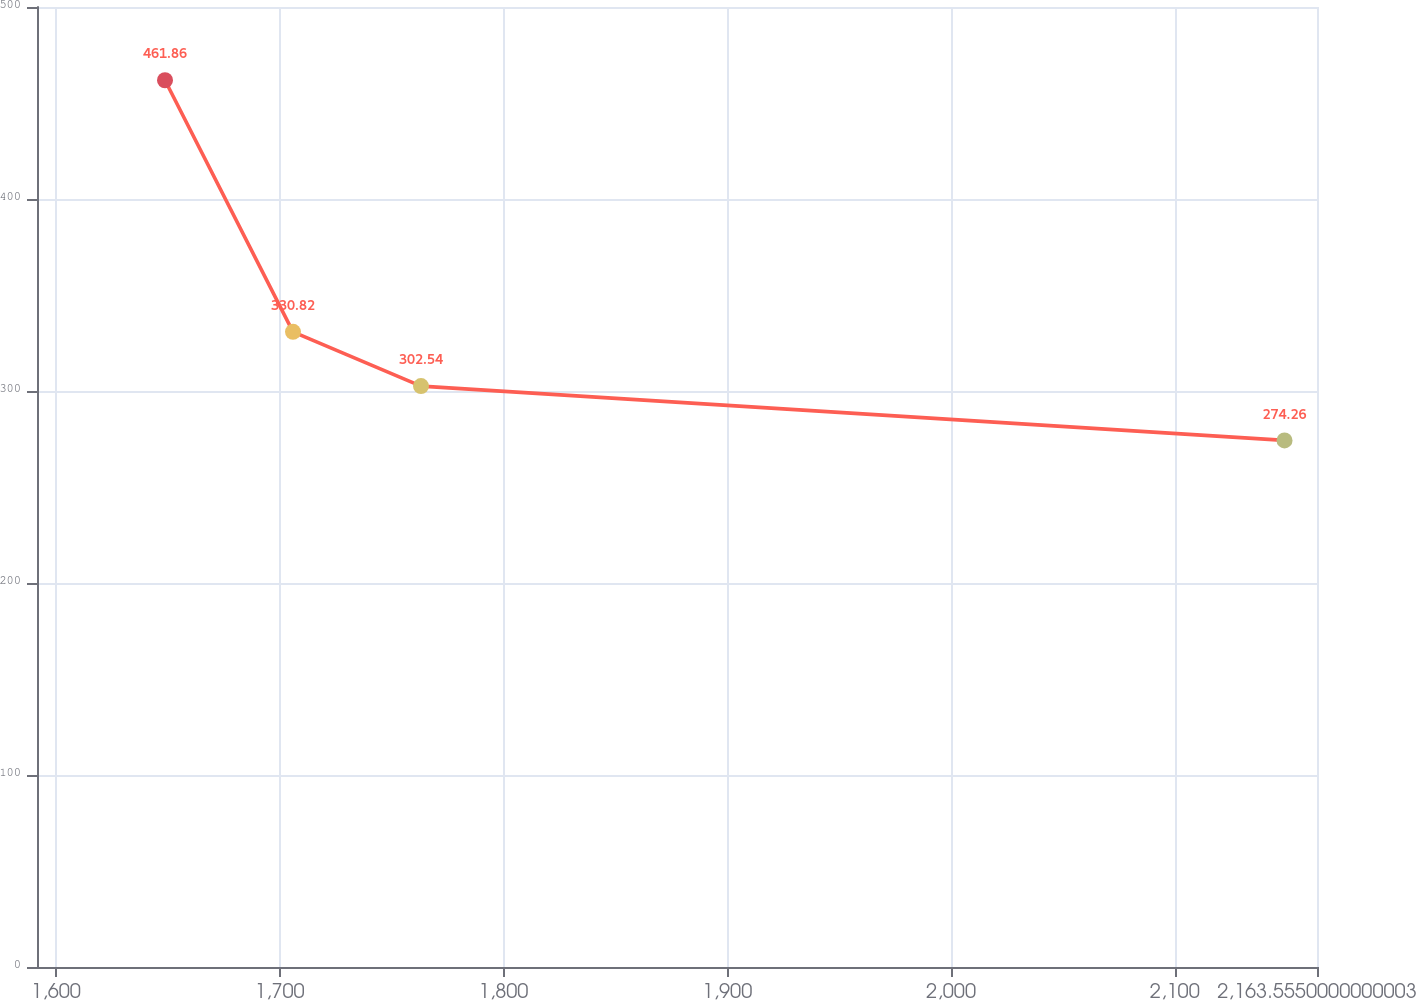<chart> <loc_0><loc_0><loc_500><loc_500><line_chart><ecel><fcel>As of December 2013<nl><fcel>1648.71<fcel>461.86<nl><fcel>1705.91<fcel>330.82<nl><fcel>1763.12<fcel>302.54<nl><fcel>2149.04<fcel>274.26<nl><fcel>2220.76<fcel>179.04<nl></chart> 